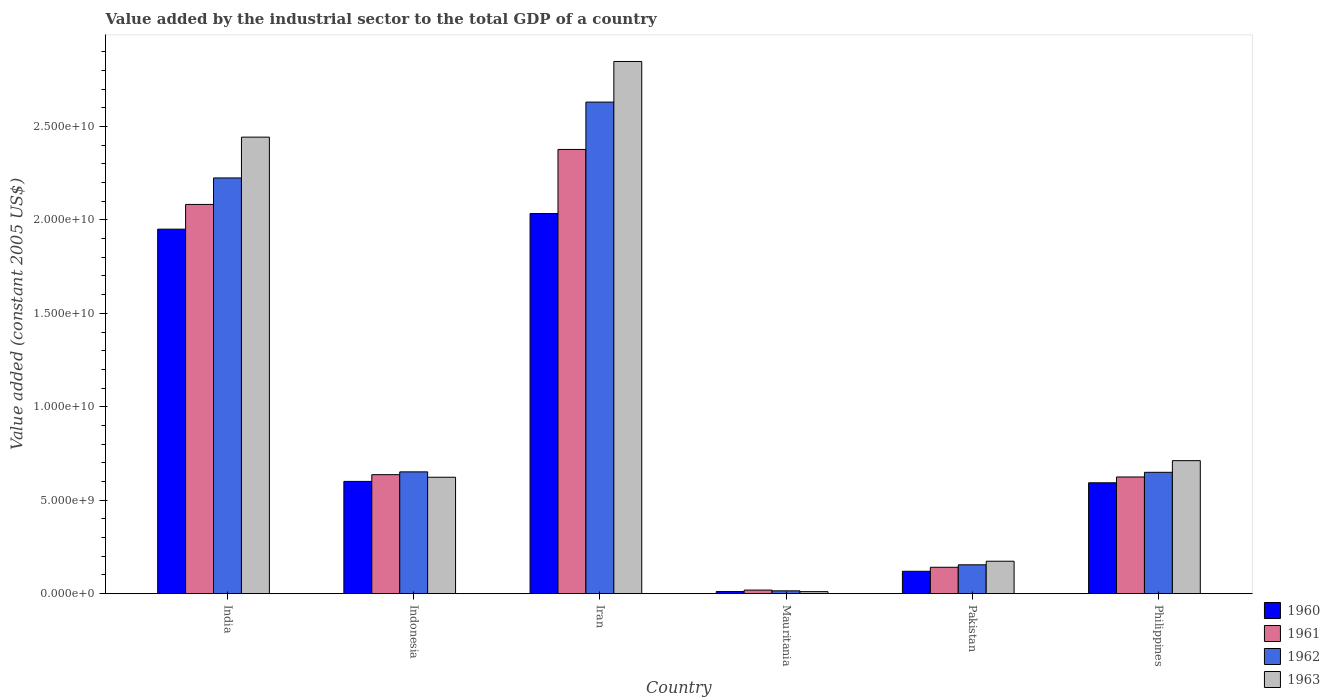How many different coloured bars are there?
Provide a succinct answer. 4. Are the number of bars per tick equal to the number of legend labels?
Give a very brief answer. Yes. Are the number of bars on each tick of the X-axis equal?
Make the answer very short. Yes. What is the label of the 2nd group of bars from the left?
Provide a succinct answer. Indonesia. What is the value added by the industrial sector in 1962 in India?
Provide a succinct answer. 2.22e+1. Across all countries, what is the maximum value added by the industrial sector in 1963?
Offer a terse response. 2.85e+1. Across all countries, what is the minimum value added by the industrial sector in 1963?
Keep it short and to the point. 1.08e+08. In which country was the value added by the industrial sector in 1960 maximum?
Your answer should be very brief. Iran. In which country was the value added by the industrial sector in 1961 minimum?
Offer a terse response. Mauritania. What is the total value added by the industrial sector in 1961 in the graph?
Make the answer very short. 5.88e+1. What is the difference between the value added by the industrial sector in 1963 in India and that in Philippines?
Give a very brief answer. 1.73e+1. What is the difference between the value added by the industrial sector in 1962 in Indonesia and the value added by the industrial sector in 1960 in Iran?
Offer a terse response. -1.38e+1. What is the average value added by the industrial sector in 1961 per country?
Provide a short and direct response. 9.80e+09. What is the difference between the value added by the industrial sector of/in 1960 and value added by the industrial sector of/in 1962 in Mauritania?
Offer a very short reply. -3.59e+07. What is the ratio of the value added by the industrial sector in 1963 in Iran to that in Mauritania?
Your response must be concise. 263.11. Is the difference between the value added by the industrial sector in 1960 in Indonesia and Pakistan greater than the difference between the value added by the industrial sector in 1962 in Indonesia and Pakistan?
Provide a succinct answer. No. What is the difference between the highest and the second highest value added by the industrial sector in 1961?
Offer a terse response. -2.94e+09. What is the difference between the highest and the lowest value added by the industrial sector in 1962?
Your answer should be compact. 2.62e+1. Is the sum of the value added by the industrial sector in 1960 in Indonesia and Philippines greater than the maximum value added by the industrial sector in 1962 across all countries?
Make the answer very short. No. Is it the case that in every country, the sum of the value added by the industrial sector in 1963 and value added by the industrial sector in 1960 is greater than the sum of value added by the industrial sector in 1961 and value added by the industrial sector in 1962?
Provide a short and direct response. No. What does the 4th bar from the left in Philippines represents?
Offer a terse response. 1963. What does the 2nd bar from the right in Mauritania represents?
Your answer should be compact. 1962. Is it the case that in every country, the sum of the value added by the industrial sector in 1960 and value added by the industrial sector in 1963 is greater than the value added by the industrial sector in 1961?
Keep it short and to the point. Yes. What is the difference between two consecutive major ticks on the Y-axis?
Offer a terse response. 5.00e+09. Are the values on the major ticks of Y-axis written in scientific E-notation?
Your response must be concise. Yes. How many legend labels are there?
Your answer should be very brief. 4. What is the title of the graph?
Your answer should be compact. Value added by the industrial sector to the total GDP of a country. Does "1960" appear as one of the legend labels in the graph?
Give a very brief answer. Yes. What is the label or title of the X-axis?
Offer a very short reply. Country. What is the label or title of the Y-axis?
Offer a terse response. Value added (constant 2005 US$). What is the Value added (constant 2005 US$) of 1960 in India?
Make the answer very short. 1.95e+1. What is the Value added (constant 2005 US$) of 1961 in India?
Your answer should be very brief. 2.08e+1. What is the Value added (constant 2005 US$) of 1962 in India?
Keep it short and to the point. 2.22e+1. What is the Value added (constant 2005 US$) in 1963 in India?
Offer a very short reply. 2.44e+1. What is the Value added (constant 2005 US$) of 1960 in Indonesia?
Provide a succinct answer. 6.01e+09. What is the Value added (constant 2005 US$) in 1961 in Indonesia?
Make the answer very short. 6.37e+09. What is the Value added (constant 2005 US$) of 1962 in Indonesia?
Your response must be concise. 6.52e+09. What is the Value added (constant 2005 US$) of 1963 in Indonesia?
Your answer should be compact. 6.23e+09. What is the Value added (constant 2005 US$) in 1960 in Iran?
Provide a short and direct response. 2.03e+1. What is the Value added (constant 2005 US$) in 1961 in Iran?
Ensure brevity in your answer.  2.38e+1. What is the Value added (constant 2005 US$) of 1962 in Iran?
Offer a very short reply. 2.63e+1. What is the Value added (constant 2005 US$) in 1963 in Iran?
Offer a very short reply. 2.85e+1. What is the Value added (constant 2005 US$) in 1960 in Mauritania?
Give a very brief answer. 1.15e+08. What is the Value added (constant 2005 US$) of 1961 in Mauritania?
Offer a terse response. 1.92e+08. What is the Value added (constant 2005 US$) of 1962 in Mauritania?
Keep it short and to the point. 1.51e+08. What is the Value added (constant 2005 US$) of 1963 in Mauritania?
Keep it short and to the point. 1.08e+08. What is the Value added (constant 2005 US$) in 1960 in Pakistan?
Your answer should be compact. 1.20e+09. What is the Value added (constant 2005 US$) in 1961 in Pakistan?
Your answer should be very brief. 1.41e+09. What is the Value added (constant 2005 US$) in 1962 in Pakistan?
Your answer should be very brief. 1.54e+09. What is the Value added (constant 2005 US$) in 1963 in Pakistan?
Give a very brief answer. 1.74e+09. What is the Value added (constant 2005 US$) of 1960 in Philippines?
Provide a succinct answer. 5.93e+09. What is the Value added (constant 2005 US$) of 1961 in Philippines?
Make the answer very short. 6.24e+09. What is the Value added (constant 2005 US$) of 1962 in Philippines?
Offer a very short reply. 6.49e+09. What is the Value added (constant 2005 US$) of 1963 in Philippines?
Make the answer very short. 7.12e+09. Across all countries, what is the maximum Value added (constant 2005 US$) of 1960?
Provide a succinct answer. 2.03e+1. Across all countries, what is the maximum Value added (constant 2005 US$) of 1961?
Provide a succinct answer. 2.38e+1. Across all countries, what is the maximum Value added (constant 2005 US$) in 1962?
Offer a terse response. 2.63e+1. Across all countries, what is the maximum Value added (constant 2005 US$) of 1963?
Keep it short and to the point. 2.85e+1. Across all countries, what is the minimum Value added (constant 2005 US$) in 1960?
Ensure brevity in your answer.  1.15e+08. Across all countries, what is the minimum Value added (constant 2005 US$) of 1961?
Keep it short and to the point. 1.92e+08. Across all countries, what is the minimum Value added (constant 2005 US$) of 1962?
Your answer should be compact. 1.51e+08. Across all countries, what is the minimum Value added (constant 2005 US$) of 1963?
Make the answer very short. 1.08e+08. What is the total Value added (constant 2005 US$) of 1960 in the graph?
Provide a short and direct response. 5.31e+1. What is the total Value added (constant 2005 US$) in 1961 in the graph?
Give a very brief answer. 5.88e+1. What is the total Value added (constant 2005 US$) in 1962 in the graph?
Offer a very short reply. 6.33e+1. What is the total Value added (constant 2005 US$) of 1963 in the graph?
Your response must be concise. 6.81e+1. What is the difference between the Value added (constant 2005 US$) in 1960 in India and that in Indonesia?
Give a very brief answer. 1.35e+1. What is the difference between the Value added (constant 2005 US$) of 1961 in India and that in Indonesia?
Keep it short and to the point. 1.45e+1. What is the difference between the Value added (constant 2005 US$) in 1962 in India and that in Indonesia?
Offer a terse response. 1.57e+1. What is the difference between the Value added (constant 2005 US$) in 1963 in India and that in Indonesia?
Keep it short and to the point. 1.82e+1. What is the difference between the Value added (constant 2005 US$) in 1960 in India and that in Iran?
Offer a terse response. -8.36e+08. What is the difference between the Value added (constant 2005 US$) in 1961 in India and that in Iran?
Provide a short and direct response. -2.94e+09. What is the difference between the Value added (constant 2005 US$) in 1962 in India and that in Iran?
Give a very brief answer. -4.06e+09. What is the difference between the Value added (constant 2005 US$) in 1963 in India and that in Iran?
Offer a terse response. -4.05e+09. What is the difference between the Value added (constant 2005 US$) in 1960 in India and that in Mauritania?
Offer a very short reply. 1.94e+1. What is the difference between the Value added (constant 2005 US$) in 1961 in India and that in Mauritania?
Your response must be concise. 2.06e+1. What is the difference between the Value added (constant 2005 US$) in 1962 in India and that in Mauritania?
Give a very brief answer. 2.21e+1. What is the difference between the Value added (constant 2005 US$) of 1963 in India and that in Mauritania?
Give a very brief answer. 2.43e+1. What is the difference between the Value added (constant 2005 US$) in 1960 in India and that in Pakistan?
Your answer should be compact. 1.83e+1. What is the difference between the Value added (constant 2005 US$) in 1961 in India and that in Pakistan?
Ensure brevity in your answer.  1.94e+1. What is the difference between the Value added (constant 2005 US$) of 1962 in India and that in Pakistan?
Your response must be concise. 2.07e+1. What is the difference between the Value added (constant 2005 US$) of 1963 in India and that in Pakistan?
Your answer should be compact. 2.27e+1. What is the difference between the Value added (constant 2005 US$) in 1960 in India and that in Philippines?
Keep it short and to the point. 1.36e+1. What is the difference between the Value added (constant 2005 US$) of 1961 in India and that in Philippines?
Ensure brevity in your answer.  1.46e+1. What is the difference between the Value added (constant 2005 US$) in 1962 in India and that in Philippines?
Offer a very short reply. 1.58e+1. What is the difference between the Value added (constant 2005 US$) of 1963 in India and that in Philippines?
Provide a short and direct response. 1.73e+1. What is the difference between the Value added (constant 2005 US$) of 1960 in Indonesia and that in Iran?
Your answer should be very brief. -1.43e+1. What is the difference between the Value added (constant 2005 US$) of 1961 in Indonesia and that in Iran?
Provide a short and direct response. -1.74e+1. What is the difference between the Value added (constant 2005 US$) of 1962 in Indonesia and that in Iran?
Keep it short and to the point. -1.98e+1. What is the difference between the Value added (constant 2005 US$) of 1963 in Indonesia and that in Iran?
Offer a very short reply. -2.22e+1. What is the difference between the Value added (constant 2005 US$) of 1960 in Indonesia and that in Mauritania?
Provide a succinct answer. 5.89e+09. What is the difference between the Value added (constant 2005 US$) of 1961 in Indonesia and that in Mauritania?
Give a very brief answer. 6.17e+09. What is the difference between the Value added (constant 2005 US$) in 1962 in Indonesia and that in Mauritania?
Offer a very short reply. 6.37e+09. What is the difference between the Value added (constant 2005 US$) in 1963 in Indonesia and that in Mauritania?
Your response must be concise. 6.12e+09. What is the difference between the Value added (constant 2005 US$) in 1960 in Indonesia and that in Pakistan?
Make the answer very short. 4.81e+09. What is the difference between the Value added (constant 2005 US$) in 1961 in Indonesia and that in Pakistan?
Ensure brevity in your answer.  4.96e+09. What is the difference between the Value added (constant 2005 US$) in 1962 in Indonesia and that in Pakistan?
Give a very brief answer. 4.97e+09. What is the difference between the Value added (constant 2005 US$) in 1963 in Indonesia and that in Pakistan?
Keep it short and to the point. 4.49e+09. What is the difference between the Value added (constant 2005 US$) in 1960 in Indonesia and that in Philippines?
Provide a succinct answer. 7.44e+07. What is the difference between the Value added (constant 2005 US$) in 1961 in Indonesia and that in Philippines?
Offer a terse response. 1.23e+08. What is the difference between the Value added (constant 2005 US$) of 1962 in Indonesia and that in Philippines?
Offer a terse response. 2.37e+07. What is the difference between the Value added (constant 2005 US$) in 1963 in Indonesia and that in Philippines?
Make the answer very short. -8.88e+08. What is the difference between the Value added (constant 2005 US$) of 1960 in Iran and that in Mauritania?
Your answer should be very brief. 2.02e+1. What is the difference between the Value added (constant 2005 US$) in 1961 in Iran and that in Mauritania?
Your answer should be compact. 2.36e+1. What is the difference between the Value added (constant 2005 US$) of 1962 in Iran and that in Mauritania?
Keep it short and to the point. 2.62e+1. What is the difference between the Value added (constant 2005 US$) of 1963 in Iran and that in Mauritania?
Make the answer very short. 2.84e+1. What is the difference between the Value added (constant 2005 US$) of 1960 in Iran and that in Pakistan?
Your answer should be very brief. 1.91e+1. What is the difference between the Value added (constant 2005 US$) of 1961 in Iran and that in Pakistan?
Provide a succinct answer. 2.24e+1. What is the difference between the Value added (constant 2005 US$) of 1962 in Iran and that in Pakistan?
Offer a terse response. 2.48e+1. What is the difference between the Value added (constant 2005 US$) in 1963 in Iran and that in Pakistan?
Keep it short and to the point. 2.67e+1. What is the difference between the Value added (constant 2005 US$) in 1960 in Iran and that in Philippines?
Give a very brief answer. 1.44e+1. What is the difference between the Value added (constant 2005 US$) in 1961 in Iran and that in Philippines?
Your answer should be compact. 1.75e+1. What is the difference between the Value added (constant 2005 US$) in 1962 in Iran and that in Philippines?
Your answer should be very brief. 1.98e+1. What is the difference between the Value added (constant 2005 US$) in 1963 in Iran and that in Philippines?
Provide a short and direct response. 2.14e+1. What is the difference between the Value added (constant 2005 US$) of 1960 in Mauritania and that in Pakistan?
Ensure brevity in your answer.  -1.08e+09. What is the difference between the Value added (constant 2005 US$) of 1961 in Mauritania and that in Pakistan?
Your answer should be compact. -1.22e+09. What is the difference between the Value added (constant 2005 US$) in 1962 in Mauritania and that in Pakistan?
Give a very brief answer. -1.39e+09. What is the difference between the Value added (constant 2005 US$) in 1963 in Mauritania and that in Pakistan?
Give a very brief answer. -1.63e+09. What is the difference between the Value added (constant 2005 US$) in 1960 in Mauritania and that in Philippines?
Your answer should be compact. -5.82e+09. What is the difference between the Value added (constant 2005 US$) of 1961 in Mauritania and that in Philippines?
Your response must be concise. -6.05e+09. What is the difference between the Value added (constant 2005 US$) of 1962 in Mauritania and that in Philippines?
Offer a very short reply. -6.34e+09. What is the difference between the Value added (constant 2005 US$) of 1963 in Mauritania and that in Philippines?
Your response must be concise. -7.01e+09. What is the difference between the Value added (constant 2005 US$) in 1960 in Pakistan and that in Philippines?
Your answer should be very brief. -4.73e+09. What is the difference between the Value added (constant 2005 US$) of 1961 in Pakistan and that in Philippines?
Give a very brief answer. -4.83e+09. What is the difference between the Value added (constant 2005 US$) of 1962 in Pakistan and that in Philippines?
Ensure brevity in your answer.  -4.95e+09. What is the difference between the Value added (constant 2005 US$) in 1963 in Pakistan and that in Philippines?
Give a very brief answer. -5.38e+09. What is the difference between the Value added (constant 2005 US$) of 1960 in India and the Value added (constant 2005 US$) of 1961 in Indonesia?
Give a very brief answer. 1.31e+1. What is the difference between the Value added (constant 2005 US$) in 1960 in India and the Value added (constant 2005 US$) in 1962 in Indonesia?
Provide a succinct answer. 1.30e+1. What is the difference between the Value added (constant 2005 US$) of 1960 in India and the Value added (constant 2005 US$) of 1963 in Indonesia?
Keep it short and to the point. 1.33e+1. What is the difference between the Value added (constant 2005 US$) in 1961 in India and the Value added (constant 2005 US$) in 1962 in Indonesia?
Offer a terse response. 1.43e+1. What is the difference between the Value added (constant 2005 US$) in 1961 in India and the Value added (constant 2005 US$) in 1963 in Indonesia?
Give a very brief answer. 1.46e+1. What is the difference between the Value added (constant 2005 US$) in 1962 in India and the Value added (constant 2005 US$) in 1963 in Indonesia?
Provide a succinct answer. 1.60e+1. What is the difference between the Value added (constant 2005 US$) in 1960 in India and the Value added (constant 2005 US$) in 1961 in Iran?
Your response must be concise. -4.27e+09. What is the difference between the Value added (constant 2005 US$) in 1960 in India and the Value added (constant 2005 US$) in 1962 in Iran?
Offer a very short reply. -6.80e+09. What is the difference between the Value added (constant 2005 US$) of 1960 in India and the Value added (constant 2005 US$) of 1963 in Iran?
Make the answer very short. -8.97e+09. What is the difference between the Value added (constant 2005 US$) of 1961 in India and the Value added (constant 2005 US$) of 1962 in Iran?
Provide a short and direct response. -5.48e+09. What is the difference between the Value added (constant 2005 US$) in 1961 in India and the Value added (constant 2005 US$) in 1963 in Iran?
Ensure brevity in your answer.  -7.65e+09. What is the difference between the Value added (constant 2005 US$) in 1962 in India and the Value added (constant 2005 US$) in 1963 in Iran?
Your answer should be compact. -6.23e+09. What is the difference between the Value added (constant 2005 US$) in 1960 in India and the Value added (constant 2005 US$) in 1961 in Mauritania?
Keep it short and to the point. 1.93e+1. What is the difference between the Value added (constant 2005 US$) in 1960 in India and the Value added (constant 2005 US$) in 1962 in Mauritania?
Your answer should be compact. 1.94e+1. What is the difference between the Value added (constant 2005 US$) of 1960 in India and the Value added (constant 2005 US$) of 1963 in Mauritania?
Ensure brevity in your answer.  1.94e+1. What is the difference between the Value added (constant 2005 US$) in 1961 in India and the Value added (constant 2005 US$) in 1962 in Mauritania?
Ensure brevity in your answer.  2.07e+1. What is the difference between the Value added (constant 2005 US$) in 1961 in India and the Value added (constant 2005 US$) in 1963 in Mauritania?
Offer a terse response. 2.07e+1. What is the difference between the Value added (constant 2005 US$) of 1962 in India and the Value added (constant 2005 US$) of 1963 in Mauritania?
Your answer should be compact. 2.21e+1. What is the difference between the Value added (constant 2005 US$) of 1960 in India and the Value added (constant 2005 US$) of 1961 in Pakistan?
Provide a succinct answer. 1.81e+1. What is the difference between the Value added (constant 2005 US$) of 1960 in India and the Value added (constant 2005 US$) of 1962 in Pakistan?
Offer a terse response. 1.80e+1. What is the difference between the Value added (constant 2005 US$) in 1960 in India and the Value added (constant 2005 US$) in 1963 in Pakistan?
Your answer should be compact. 1.78e+1. What is the difference between the Value added (constant 2005 US$) of 1961 in India and the Value added (constant 2005 US$) of 1962 in Pakistan?
Offer a terse response. 1.93e+1. What is the difference between the Value added (constant 2005 US$) of 1961 in India and the Value added (constant 2005 US$) of 1963 in Pakistan?
Give a very brief answer. 1.91e+1. What is the difference between the Value added (constant 2005 US$) in 1962 in India and the Value added (constant 2005 US$) in 1963 in Pakistan?
Provide a short and direct response. 2.05e+1. What is the difference between the Value added (constant 2005 US$) of 1960 in India and the Value added (constant 2005 US$) of 1961 in Philippines?
Make the answer very short. 1.33e+1. What is the difference between the Value added (constant 2005 US$) of 1960 in India and the Value added (constant 2005 US$) of 1962 in Philippines?
Your response must be concise. 1.30e+1. What is the difference between the Value added (constant 2005 US$) in 1960 in India and the Value added (constant 2005 US$) in 1963 in Philippines?
Your answer should be compact. 1.24e+1. What is the difference between the Value added (constant 2005 US$) in 1961 in India and the Value added (constant 2005 US$) in 1962 in Philippines?
Provide a succinct answer. 1.43e+1. What is the difference between the Value added (constant 2005 US$) in 1961 in India and the Value added (constant 2005 US$) in 1963 in Philippines?
Make the answer very short. 1.37e+1. What is the difference between the Value added (constant 2005 US$) of 1962 in India and the Value added (constant 2005 US$) of 1963 in Philippines?
Make the answer very short. 1.51e+1. What is the difference between the Value added (constant 2005 US$) of 1960 in Indonesia and the Value added (constant 2005 US$) of 1961 in Iran?
Your response must be concise. -1.78e+1. What is the difference between the Value added (constant 2005 US$) in 1960 in Indonesia and the Value added (constant 2005 US$) in 1962 in Iran?
Offer a very short reply. -2.03e+1. What is the difference between the Value added (constant 2005 US$) in 1960 in Indonesia and the Value added (constant 2005 US$) in 1963 in Iran?
Make the answer very short. -2.25e+1. What is the difference between the Value added (constant 2005 US$) of 1961 in Indonesia and the Value added (constant 2005 US$) of 1962 in Iran?
Offer a terse response. -1.99e+1. What is the difference between the Value added (constant 2005 US$) in 1961 in Indonesia and the Value added (constant 2005 US$) in 1963 in Iran?
Offer a very short reply. -2.21e+1. What is the difference between the Value added (constant 2005 US$) in 1962 in Indonesia and the Value added (constant 2005 US$) in 1963 in Iran?
Offer a terse response. -2.20e+1. What is the difference between the Value added (constant 2005 US$) of 1960 in Indonesia and the Value added (constant 2005 US$) of 1961 in Mauritania?
Offer a very short reply. 5.81e+09. What is the difference between the Value added (constant 2005 US$) in 1960 in Indonesia and the Value added (constant 2005 US$) in 1962 in Mauritania?
Offer a very short reply. 5.86e+09. What is the difference between the Value added (constant 2005 US$) in 1960 in Indonesia and the Value added (constant 2005 US$) in 1963 in Mauritania?
Offer a very short reply. 5.90e+09. What is the difference between the Value added (constant 2005 US$) in 1961 in Indonesia and the Value added (constant 2005 US$) in 1962 in Mauritania?
Provide a short and direct response. 6.22e+09. What is the difference between the Value added (constant 2005 US$) in 1961 in Indonesia and the Value added (constant 2005 US$) in 1963 in Mauritania?
Make the answer very short. 6.26e+09. What is the difference between the Value added (constant 2005 US$) in 1962 in Indonesia and the Value added (constant 2005 US$) in 1963 in Mauritania?
Offer a very short reply. 6.41e+09. What is the difference between the Value added (constant 2005 US$) in 1960 in Indonesia and the Value added (constant 2005 US$) in 1961 in Pakistan?
Offer a very short reply. 4.60e+09. What is the difference between the Value added (constant 2005 US$) in 1960 in Indonesia and the Value added (constant 2005 US$) in 1962 in Pakistan?
Give a very brief answer. 4.46e+09. What is the difference between the Value added (constant 2005 US$) of 1960 in Indonesia and the Value added (constant 2005 US$) of 1963 in Pakistan?
Your answer should be very brief. 4.27e+09. What is the difference between the Value added (constant 2005 US$) in 1961 in Indonesia and the Value added (constant 2005 US$) in 1962 in Pakistan?
Make the answer very short. 4.82e+09. What is the difference between the Value added (constant 2005 US$) in 1961 in Indonesia and the Value added (constant 2005 US$) in 1963 in Pakistan?
Your answer should be compact. 4.63e+09. What is the difference between the Value added (constant 2005 US$) in 1962 in Indonesia and the Value added (constant 2005 US$) in 1963 in Pakistan?
Your answer should be compact. 4.78e+09. What is the difference between the Value added (constant 2005 US$) in 1960 in Indonesia and the Value added (constant 2005 US$) in 1961 in Philippines?
Your answer should be compact. -2.37e+08. What is the difference between the Value added (constant 2005 US$) of 1960 in Indonesia and the Value added (constant 2005 US$) of 1962 in Philippines?
Provide a succinct answer. -4.86e+08. What is the difference between the Value added (constant 2005 US$) of 1960 in Indonesia and the Value added (constant 2005 US$) of 1963 in Philippines?
Provide a short and direct response. -1.11e+09. What is the difference between the Value added (constant 2005 US$) in 1961 in Indonesia and the Value added (constant 2005 US$) in 1962 in Philippines?
Offer a terse response. -1.26e+08. What is the difference between the Value added (constant 2005 US$) of 1961 in Indonesia and the Value added (constant 2005 US$) of 1963 in Philippines?
Make the answer very short. -7.50e+08. What is the difference between the Value added (constant 2005 US$) in 1962 in Indonesia and the Value added (constant 2005 US$) in 1963 in Philippines?
Your response must be concise. -6.01e+08. What is the difference between the Value added (constant 2005 US$) in 1960 in Iran and the Value added (constant 2005 US$) in 1961 in Mauritania?
Provide a succinct answer. 2.01e+1. What is the difference between the Value added (constant 2005 US$) in 1960 in Iran and the Value added (constant 2005 US$) in 1962 in Mauritania?
Your response must be concise. 2.02e+1. What is the difference between the Value added (constant 2005 US$) of 1960 in Iran and the Value added (constant 2005 US$) of 1963 in Mauritania?
Offer a very short reply. 2.02e+1. What is the difference between the Value added (constant 2005 US$) in 1961 in Iran and the Value added (constant 2005 US$) in 1962 in Mauritania?
Make the answer very short. 2.36e+1. What is the difference between the Value added (constant 2005 US$) in 1961 in Iran and the Value added (constant 2005 US$) in 1963 in Mauritania?
Keep it short and to the point. 2.37e+1. What is the difference between the Value added (constant 2005 US$) in 1962 in Iran and the Value added (constant 2005 US$) in 1963 in Mauritania?
Offer a very short reply. 2.62e+1. What is the difference between the Value added (constant 2005 US$) of 1960 in Iran and the Value added (constant 2005 US$) of 1961 in Pakistan?
Your answer should be compact. 1.89e+1. What is the difference between the Value added (constant 2005 US$) of 1960 in Iran and the Value added (constant 2005 US$) of 1962 in Pakistan?
Your answer should be very brief. 1.88e+1. What is the difference between the Value added (constant 2005 US$) in 1960 in Iran and the Value added (constant 2005 US$) in 1963 in Pakistan?
Provide a succinct answer. 1.86e+1. What is the difference between the Value added (constant 2005 US$) of 1961 in Iran and the Value added (constant 2005 US$) of 1962 in Pakistan?
Your response must be concise. 2.22e+1. What is the difference between the Value added (constant 2005 US$) in 1961 in Iran and the Value added (constant 2005 US$) in 1963 in Pakistan?
Keep it short and to the point. 2.20e+1. What is the difference between the Value added (constant 2005 US$) in 1962 in Iran and the Value added (constant 2005 US$) in 1963 in Pakistan?
Make the answer very short. 2.46e+1. What is the difference between the Value added (constant 2005 US$) in 1960 in Iran and the Value added (constant 2005 US$) in 1961 in Philippines?
Ensure brevity in your answer.  1.41e+1. What is the difference between the Value added (constant 2005 US$) in 1960 in Iran and the Value added (constant 2005 US$) in 1962 in Philippines?
Give a very brief answer. 1.38e+1. What is the difference between the Value added (constant 2005 US$) in 1960 in Iran and the Value added (constant 2005 US$) in 1963 in Philippines?
Ensure brevity in your answer.  1.32e+1. What is the difference between the Value added (constant 2005 US$) in 1961 in Iran and the Value added (constant 2005 US$) in 1962 in Philippines?
Keep it short and to the point. 1.73e+1. What is the difference between the Value added (constant 2005 US$) of 1961 in Iran and the Value added (constant 2005 US$) of 1963 in Philippines?
Give a very brief answer. 1.67e+1. What is the difference between the Value added (constant 2005 US$) of 1962 in Iran and the Value added (constant 2005 US$) of 1963 in Philippines?
Your answer should be compact. 1.92e+1. What is the difference between the Value added (constant 2005 US$) in 1960 in Mauritania and the Value added (constant 2005 US$) in 1961 in Pakistan?
Keep it short and to the point. -1.30e+09. What is the difference between the Value added (constant 2005 US$) in 1960 in Mauritania and the Value added (constant 2005 US$) in 1962 in Pakistan?
Make the answer very short. -1.43e+09. What is the difference between the Value added (constant 2005 US$) in 1960 in Mauritania and the Value added (constant 2005 US$) in 1963 in Pakistan?
Give a very brief answer. -1.62e+09. What is the difference between the Value added (constant 2005 US$) of 1961 in Mauritania and the Value added (constant 2005 US$) of 1962 in Pakistan?
Ensure brevity in your answer.  -1.35e+09. What is the difference between the Value added (constant 2005 US$) of 1961 in Mauritania and the Value added (constant 2005 US$) of 1963 in Pakistan?
Provide a succinct answer. -1.54e+09. What is the difference between the Value added (constant 2005 US$) in 1962 in Mauritania and the Value added (constant 2005 US$) in 1963 in Pakistan?
Ensure brevity in your answer.  -1.58e+09. What is the difference between the Value added (constant 2005 US$) of 1960 in Mauritania and the Value added (constant 2005 US$) of 1961 in Philippines?
Keep it short and to the point. -6.13e+09. What is the difference between the Value added (constant 2005 US$) in 1960 in Mauritania and the Value added (constant 2005 US$) in 1962 in Philippines?
Give a very brief answer. -6.38e+09. What is the difference between the Value added (constant 2005 US$) in 1960 in Mauritania and the Value added (constant 2005 US$) in 1963 in Philippines?
Offer a terse response. -7.00e+09. What is the difference between the Value added (constant 2005 US$) in 1961 in Mauritania and the Value added (constant 2005 US$) in 1962 in Philippines?
Your response must be concise. -6.30e+09. What is the difference between the Value added (constant 2005 US$) in 1961 in Mauritania and the Value added (constant 2005 US$) in 1963 in Philippines?
Your answer should be very brief. -6.93e+09. What is the difference between the Value added (constant 2005 US$) in 1962 in Mauritania and the Value added (constant 2005 US$) in 1963 in Philippines?
Offer a terse response. -6.97e+09. What is the difference between the Value added (constant 2005 US$) of 1960 in Pakistan and the Value added (constant 2005 US$) of 1961 in Philippines?
Your response must be concise. -5.05e+09. What is the difference between the Value added (constant 2005 US$) in 1960 in Pakistan and the Value added (constant 2005 US$) in 1962 in Philippines?
Offer a terse response. -5.30e+09. What is the difference between the Value added (constant 2005 US$) in 1960 in Pakistan and the Value added (constant 2005 US$) in 1963 in Philippines?
Offer a terse response. -5.92e+09. What is the difference between the Value added (constant 2005 US$) of 1961 in Pakistan and the Value added (constant 2005 US$) of 1962 in Philippines?
Keep it short and to the point. -5.08e+09. What is the difference between the Value added (constant 2005 US$) in 1961 in Pakistan and the Value added (constant 2005 US$) in 1963 in Philippines?
Give a very brief answer. -5.71e+09. What is the difference between the Value added (constant 2005 US$) of 1962 in Pakistan and the Value added (constant 2005 US$) of 1963 in Philippines?
Offer a very short reply. -5.57e+09. What is the average Value added (constant 2005 US$) in 1960 per country?
Your answer should be very brief. 8.85e+09. What is the average Value added (constant 2005 US$) in 1961 per country?
Provide a succinct answer. 9.80e+09. What is the average Value added (constant 2005 US$) of 1962 per country?
Provide a short and direct response. 1.05e+1. What is the average Value added (constant 2005 US$) in 1963 per country?
Provide a short and direct response. 1.13e+1. What is the difference between the Value added (constant 2005 US$) of 1960 and Value added (constant 2005 US$) of 1961 in India?
Your answer should be very brief. -1.32e+09. What is the difference between the Value added (constant 2005 US$) of 1960 and Value added (constant 2005 US$) of 1962 in India?
Keep it short and to the point. -2.74e+09. What is the difference between the Value added (constant 2005 US$) of 1960 and Value added (constant 2005 US$) of 1963 in India?
Ensure brevity in your answer.  -4.92e+09. What is the difference between the Value added (constant 2005 US$) of 1961 and Value added (constant 2005 US$) of 1962 in India?
Offer a terse response. -1.42e+09. What is the difference between the Value added (constant 2005 US$) in 1961 and Value added (constant 2005 US$) in 1963 in India?
Give a very brief answer. -3.60e+09. What is the difference between the Value added (constant 2005 US$) in 1962 and Value added (constant 2005 US$) in 1963 in India?
Your answer should be compact. -2.18e+09. What is the difference between the Value added (constant 2005 US$) of 1960 and Value added (constant 2005 US$) of 1961 in Indonesia?
Your answer should be very brief. -3.60e+08. What is the difference between the Value added (constant 2005 US$) in 1960 and Value added (constant 2005 US$) in 1962 in Indonesia?
Provide a short and direct response. -5.10e+08. What is the difference between the Value added (constant 2005 US$) in 1960 and Value added (constant 2005 US$) in 1963 in Indonesia?
Give a very brief answer. -2.22e+08. What is the difference between the Value added (constant 2005 US$) in 1961 and Value added (constant 2005 US$) in 1962 in Indonesia?
Your answer should be compact. -1.50e+08. What is the difference between the Value added (constant 2005 US$) in 1961 and Value added (constant 2005 US$) in 1963 in Indonesia?
Offer a very short reply. 1.38e+08. What is the difference between the Value added (constant 2005 US$) of 1962 and Value added (constant 2005 US$) of 1963 in Indonesia?
Keep it short and to the point. 2.88e+08. What is the difference between the Value added (constant 2005 US$) of 1960 and Value added (constant 2005 US$) of 1961 in Iran?
Your response must be concise. -3.43e+09. What is the difference between the Value added (constant 2005 US$) of 1960 and Value added (constant 2005 US$) of 1962 in Iran?
Provide a short and direct response. -5.96e+09. What is the difference between the Value added (constant 2005 US$) in 1960 and Value added (constant 2005 US$) in 1963 in Iran?
Keep it short and to the point. -8.14e+09. What is the difference between the Value added (constant 2005 US$) of 1961 and Value added (constant 2005 US$) of 1962 in Iran?
Your answer should be very brief. -2.53e+09. What is the difference between the Value added (constant 2005 US$) in 1961 and Value added (constant 2005 US$) in 1963 in Iran?
Provide a short and direct response. -4.71e+09. What is the difference between the Value added (constant 2005 US$) in 1962 and Value added (constant 2005 US$) in 1963 in Iran?
Your response must be concise. -2.17e+09. What is the difference between the Value added (constant 2005 US$) in 1960 and Value added (constant 2005 US$) in 1961 in Mauritania?
Keep it short and to the point. -7.68e+07. What is the difference between the Value added (constant 2005 US$) of 1960 and Value added (constant 2005 US$) of 1962 in Mauritania?
Make the answer very short. -3.59e+07. What is the difference between the Value added (constant 2005 US$) in 1960 and Value added (constant 2005 US$) in 1963 in Mauritania?
Provide a succinct answer. 7.13e+06. What is the difference between the Value added (constant 2005 US$) in 1961 and Value added (constant 2005 US$) in 1962 in Mauritania?
Provide a short and direct response. 4.09e+07. What is the difference between the Value added (constant 2005 US$) in 1961 and Value added (constant 2005 US$) in 1963 in Mauritania?
Offer a terse response. 8.39e+07. What is the difference between the Value added (constant 2005 US$) of 1962 and Value added (constant 2005 US$) of 1963 in Mauritania?
Make the answer very short. 4.31e+07. What is the difference between the Value added (constant 2005 US$) of 1960 and Value added (constant 2005 US$) of 1961 in Pakistan?
Provide a short and direct response. -2.14e+08. What is the difference between the Value added (constant 2005 US$) in 1960 and Value added (constant 2005 US$) in 1962 in Pakistan?
Your answer should be compact. -3.45e+08. What is the difference between the Value added (constant 2005 US$) of 1960 and Value added (constant 2005 US$) of 1963 in Pakistan?
Your answer should be very brief. -5.37e+08. What is the difference between the Value added (constant 2005 US$) in 1961 and Value added (constant 2005 US$) in 1962 in Pakistan?
Make the answer very short. -1.32e+08. What is the difference between the Value added (constant 2005 US$) of 1961 and Value added (constant 2005 US$) of 1963 in Pakistan?
Ensure brevity in your answer.  -3.23e+08. What is the difference between the Value added (constant 2005 US$) of 1962 and Value added (constant 2005 US$) of 1963 in Pakistan?
Offer a very short reply. -1.92e+08. What is the difference between the Value added (constant 2005 US$) in 1960 and Value added (constant 2005 US$) in 1961 in Philippines?
Your answer should be very brief. -3.11e+08. What is the difference between the Value added (constant 2005 US$) in 1960 and Value added (constant 2005 US$) in 1962 in Philippines?
Ensure brevity in your answer.  -5.61e+08. What is the difference between the Value added (constant 2005 US$) of 1960 and Value added (constant 2005 US$) of 1963 in Philippines?
Make the answer very short. -1.18e+09. What is the difference between the Value added (constant 2005 US$) of 1961 and Value added (constant 2005 US$) of 1962 in Philippines?
Give a very brief answer. -2.50e+08. What is the difference between the Value added (constant 2005 US$) of 1961 and Value added (constant 2005 US$) of 1963 in Philippines?
Make the answer very short. -8.74e+08. What is the difference between the Value added (constant 2005 US$) of 1962 and Value added (constant 2005 US$) of 1963 in Philippines?
Keep it short and to the point. -6.24e+08. What is the ratio of the Value added (constant 2005 US$) in 1960 in India to that in Indonesia?
Give a very brief answer. 3.25. What is the ratio of the Value added (constant 2005 US$) in 1961 in India to that in Indonesia?
Your response must be concise. 3.27. What is the ratio of the Value added (constant 2005 US$) in 1962 in India to that in Indonesia?
Offer a very short reply. 3.41. What is the ratio of the Value added (constant 2005 US$) in 1963 in India to that in Indonesia?
Provide a succinct answer. 3.92. What is the ratio of the Value added (constant 2005 US$) of 1960 in India to that in Iran?
Keep it short and to the point. 0.96. What is the ratio of the Value added (constant 2005 US$) in 1961 in India to that in Iran?
Provide a short and direct response. 0.88. What is the ratio of the Value added (constant 2005 US$) of 1962 in India to that in Iran?
Give a very brief answer. 0.85. What is the ratio of the Value added (constant 2005 US$) in 1963 in India to that in Iran?
Offer a terse response. 0.86. What is the ratio of the Value added (constant 2005 US$) in 1960 in India to that in Mauritania?
Offer a very short reply. 169.07. What is the ratio of the Value added (constant 2005 US$) in 1961 in India to that in Mauritania?
Offer a very short reply. 108.39. What is the ratio of the Value added (constant 2005 US$) of 1962 in India to that in Mauritania?
Give a very brief answer. 147.02. What is the ratio of the Value added (constant 2005 US$) of 1963 in India to that in Mauritania?
Provide a short and direct response. 225.7. What is the ratio of the Value added (constant 2005 US$) in 1960 in India to that in Pakistan?
Offer a terse response. 16.28. What is the ratio of the Value added (constant 2005 US$) in 1961 in India to that in Pakistan?
Offer a very short reply. 14.75. What is the ratio of the Value added (constant 2005 US$) in 1962 in India to that in Pakistan?
Give a very brief answer. 14.41. What is the ratio of the Value added (constant 2005 US$) of 1963 in India to that in Pakistan?
Ensure brevity in your answer.  14.08. What is the ratio of the Value added (constant 2005 US$) in 1960 in India to that in Philippines?
Provide a succinct answer. 3.29. What is the ratio of the Value added (constant 2005 US$) of 1961 in India to that in Philippines?
Your response must be concise. 3.34. What is the ratio of the Value added (constant 2005 US$) of 1962 in India to that in Philippines?
Offer a terse response. 3.43. What is the ratio of the Value added (constant 2005 US$) in 1963 in India to that in Philippines?
Your response must be concise. 3.43. What is the ratio of the Value added (constant 2005 US$) of 1960 in Indonesia to that in Iran?
Provide a short and direct response. 0.3. What is the ratio of the Value added (constant 2005 US$) in 1961 in Indonesia to that in Iran?
Your answer should be compact. 0.27. What is the ratio of the Value added (constant 2005 US$) in 1962 in Indonesia to that in Iran?
Provide a short and direct response. 0.25. What is the ratio of the Value added (constant 2005 US$) of 1963 in Indonesia to that in Iran?
Your response must be concise. 0.22. What is the ratio of the Value added (constant 2005 US$) in 1960 in Indonesia to that in Mauritania?
Keep it short and to the point. 52.07. What is the ratio of the Value added (constant 2005 US$) of 1961 in Indonesia to that in Mauritania?
Keep it short and to the point. 33.14. What is the ratio of the Value added (constant 2005 US$) of 1962 in Indonesia to that in Mauritania?
Ensure brevity in your answer.  43.07. What is the ratio of the Value added (constant 2005 US$) in 1963 in Indonesia to that in Mauritania?
Make the answer very short. 57.56. What is the ratio of the Value added (constant 2005 US$) of 1960 in Indonesia to that in Pakistan?
Your answer should be compact. 5.01. What is the ratio of the Value added (constant 2005 US$) in 1961 in Indonesia to that in Pakistan?
Ensure brevity in your answer.  4.51. What is the ratio of the Value added (constant 2005 US$) of 1962 in Indonesia to that in Pakistan?
Keep it short and to the point. 4.22. What is the ratio of the Value added (constant 2005 US$) in 1963 in Indonesia to that in Pakistan?
Offer a terse response. 3.59. What is the ratio of the Value added (constant 2005 US$) of 1960 in Indonesia to that in Philippines?
Your answer should be very brief. 1.01. What is the ratio of the Value added (constant 2005 US$) in 1961 in Indonesia to that in Philippines?
Give a very brief answer. 1.02. What is the ratio of the Value added (constant 2005 US$) in 1962 in Indonesia to that in Philippines?
Ensure brevity in your answer.  1. What is the ratio of the Value added (constant 2005 US$) of 1963 in Indonesia to that in Philippines?
Make the answer very short. 0.88. What is the ratio of the Value added (constant 2005 US$) in 1960 in Iran to that in Mauritania?
Make the answer very short. 176.32. What is the ratio of the Value added (constant 2005 US$) of 1961 in Iran to that in Mauritania?
Offer a terse response. 123.7. What is the ratio of the Value added (constant 2005 US$) of 1962 in Iran to that in Mauritania?
Keep it short and to the point. 173.84. What is the ratio of the Value added (constant 2005 US$) of 1963 in Iran to that in Mauritania?
Your answer should be very brief. 263.11. What is the ratio of the Value added (constant 2005 US$) in 1960 in Iran to that in Pakistan?
Your answer should be very brief. 16.98. What is the ratio of the Value added (constant 2005 US$) in 1961 in Iran to that in Pakistan?
Provide a short and direct response. 16.84. What is the ratio of the Value added (constant 2005 US$) in 1962 in Iran to that in Pakistan?
Your answer should be compact. 17.04. What is the ratio of the Value added (constant 2005 US$) in 1963 in Iran to that in Pakistan?
Your response must be concise. 16.41. What is the ratio of the Value added (constant 2005 US$) in 1960 in Iran to that in Philippines?
Give a very brief answer. 3.43. What is the ratio of the Value added (constant 2005 US$) of 1961 in Iran to that in Philippines?
Your response must be concise. 3.81. What is the ratio of the Value added (constant 2005 US$) in 1962 in Iran to that in Philippines?
Your response must be concise. 4.05. What is the ratio of the Value added (constant 2005 US$) of 1963 in Iran to that in Philippines?
Make the answer very short. 4. What is the ratio of the Value added (constant 2005 US$) in 1960 in Mauritania to that in Pakistan?
Your answer should be compact. 0.1. What is the ratio of the Value added (constant 2005 US$) in 1961 in Mauritania to that in Pakistan?
Give a very brief answer. 0.14. What is the ratio of the Value added (constant 2005 US$) of 1962 in Mauritania to that in Pakistan?
Offer a very short reply. 0.1. What is the ratio of the Value added (constant 2005 US$) in 1963 in Mauritania to that in Pakistan?
Your answer should be very brief. 0.06. What is the ratio of the Value added (constant 2005 US$) in 1960 in Mauritania to that in Philippines?
Make the answer very short. 0.02. What is the ratio of the Value added (constant 2005 US$) in 1961 in Mauritania to that in Philippines?
Ensure brevity in your answer.  0.03. What is the ratio of the Value added (constant 2005 US$) in 1962 in Mauritania to that in Philippines?
Provide a succinct answer. 0.02. What is the ratio of the Value added (constant 2005 US$) in 1963 in Mauritania to that in Philippines?
Provide a short and direct response. 0.02. What is the ratio of the Value added (constant 2005 US$) in 1960 in Pakistan to that in Philippines?
Your answer should be very brief. 0.2. What is the ratio of the Value added (constant 2005 US$) of 1961 in Pakistan to that in Philippines?
Provide a succinct answer. 0.23. What is the ratio of the Value added (constant 2005 US$) of 1962 in Pakistan to that in Philippines?
Offer a very short reply. 0.24. What is the ratio of the Value added (constant 2005 US$) of 1963 in Pakistan to that in Philippines?
Provide a succinct answer. 0.24. What is the difference between the highest and the second highest Value added (constant 2005 US$) of 1960?
Offer a terse response. 8.36e+08. What is the difference between the highest and the second highest Value added (constant 2005 US$) of 1961?
Keep it short and to the point. 2.94e+09. What is the difference between the highest and the second highest Value added (constant 2005 US$) of 1962?
Your response must be concise. 4.06e+09. What is the difference between the highest and the second highest Value added (constant 2005 US$) of 1963?
Ensure brevity in your answer.  4.05e+09. What is the difference between the highest and the lowest Value added (constant 2005 US$) in 1960?
Keep it short and to the point. 2.02e+1. What is the difference between the highest and the lowest Value added (constant 2005 US$) of 1961?
Provide a short and direct response. 2.36e+1. What is the difference between the highest and the lowest Value added (constant 2005 US$) in 1962?
Provide a short and direct response. 2.62e+1. What is the difference between the highest and the lowest Value added (constant 2005 US$) of 1963?
Your answer should be very brief. 2.84e+1. 